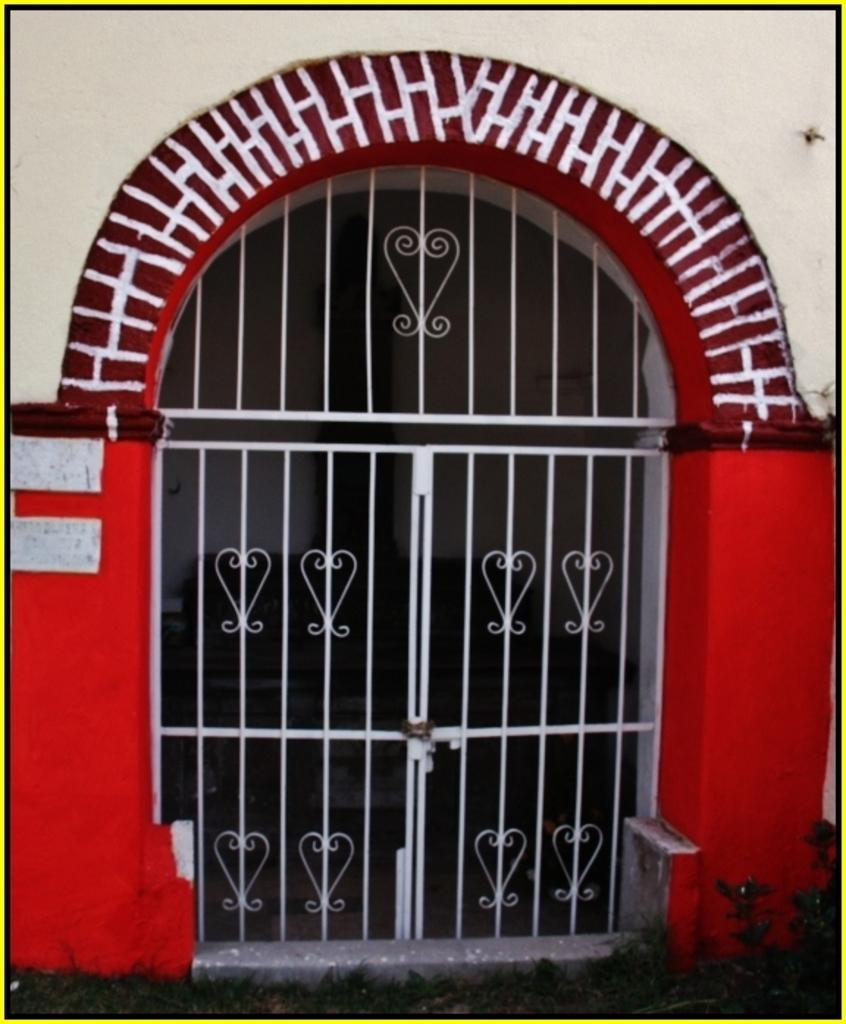What type of structure can be seen in the image? There is a wall in the image. What is the appearance of the gate in the image? There is a colorful gate in the image. What unit of measurement is used to describe the height of the gate in the image? There is no specific unit of measurement provided in the image, and the height of the gate cannot be determined from the image alone. 